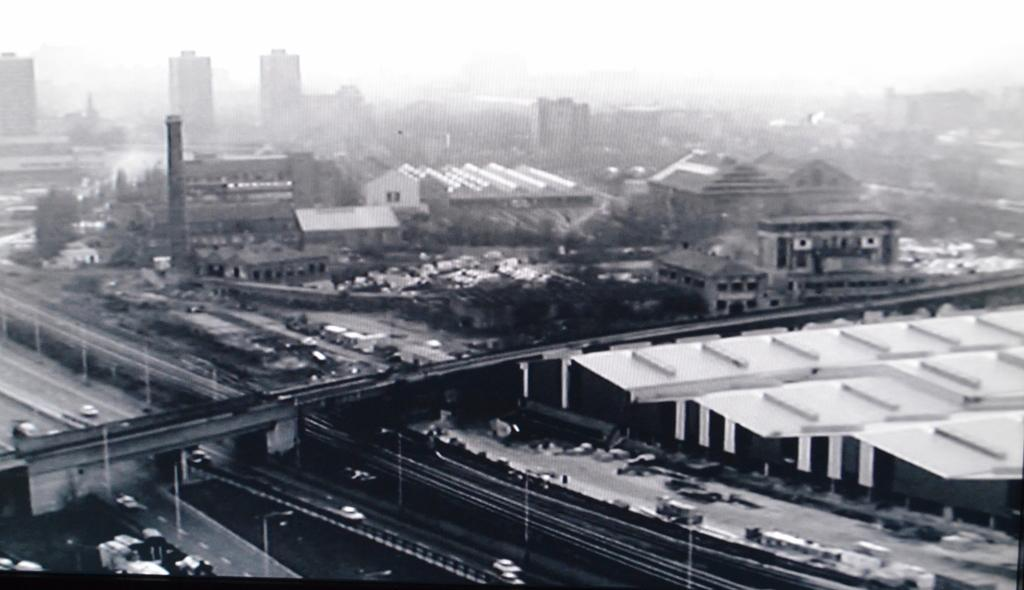What is the color scheme of the image? The image is black and white. What is the main subject of the image? The image depicts a city. What structures can be seen in the image? There are buildings, a flyover, and poles in the image. What are the sources of light in the image? There are lights in the image. What type of transportation is visible in the image? There are vehicles in the image. What type of vegetation can be seen in the image? There are trees in the image. What is visible in the background of the image? The sky is visible in the background of the image. Where is the mailbox located in the image? There is no mailbox present in the image. What type of stove is visible in the image? There is no stove present in the image. 